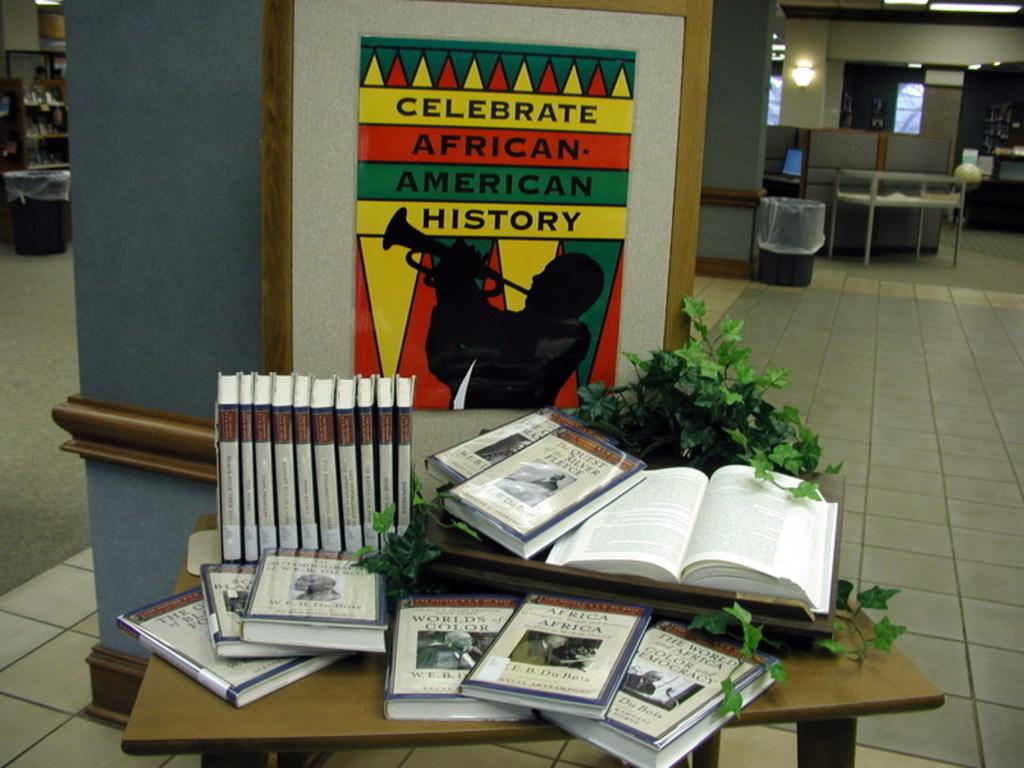<image>
Write a terse but informative summary of the picture. Celebrate African American History, advises a wall hanging in front of a table full of books. 